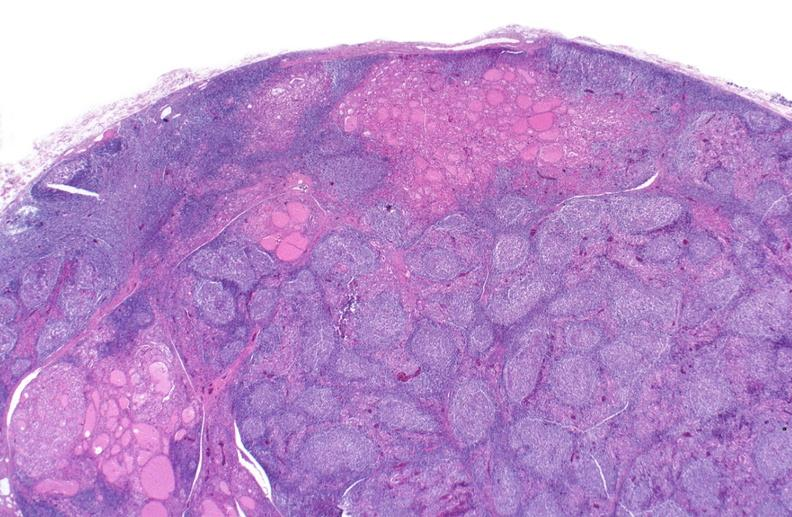what is present?
Answer the question using a single word or phrase. Endocrine 